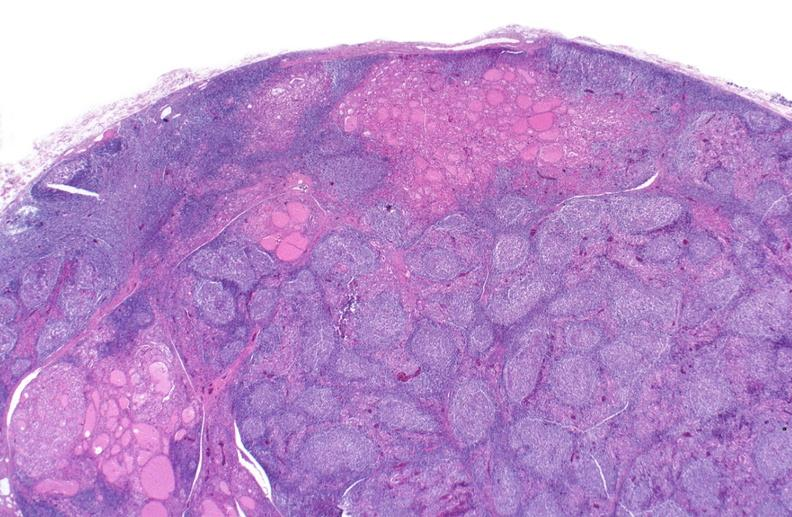what is present?
Answer the question using a single word or phrase. Endocrine 